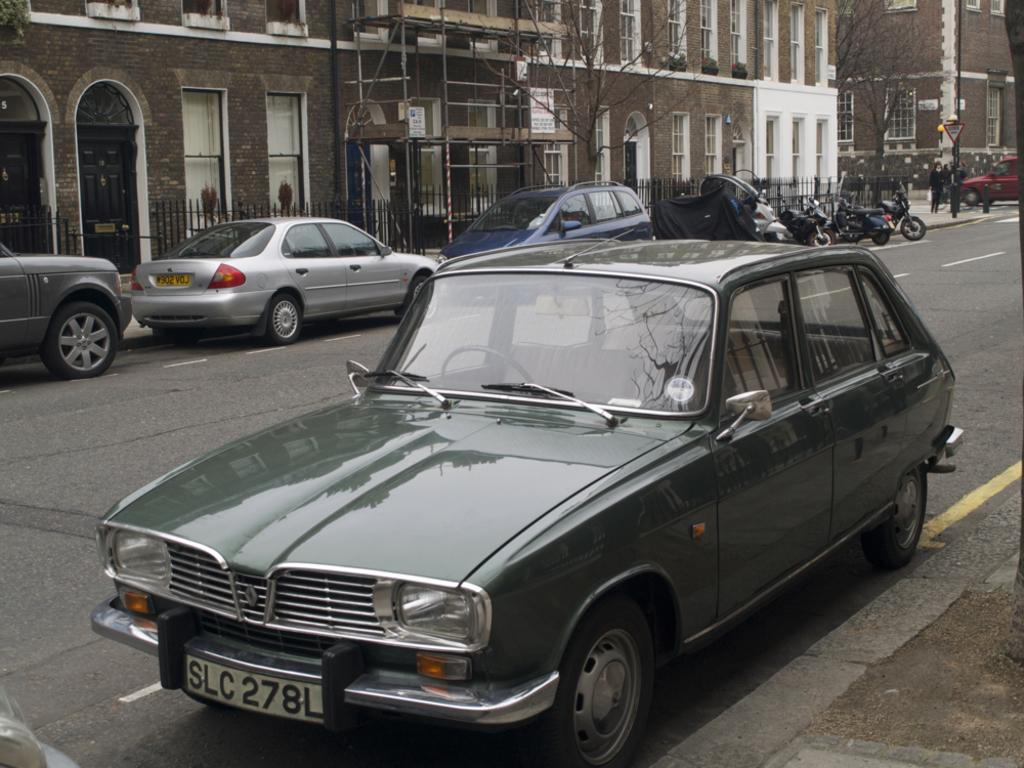What can be seen on the road in the image? There are vehicles on the road in the image. Who or what else is present in the image? There are people in the image. What can be seen in the distance, behind the people and vehicles? There are buildings, trees, poles, and railings in the background of the image. What type of dinner is being served in the image? There is no dinner present in the image; it features vehicles on the road, people, and various background elements. Can you describe the flight path of the airplane in the image? There is no airplane present in the image, so it is not possible to describe a flight path. 